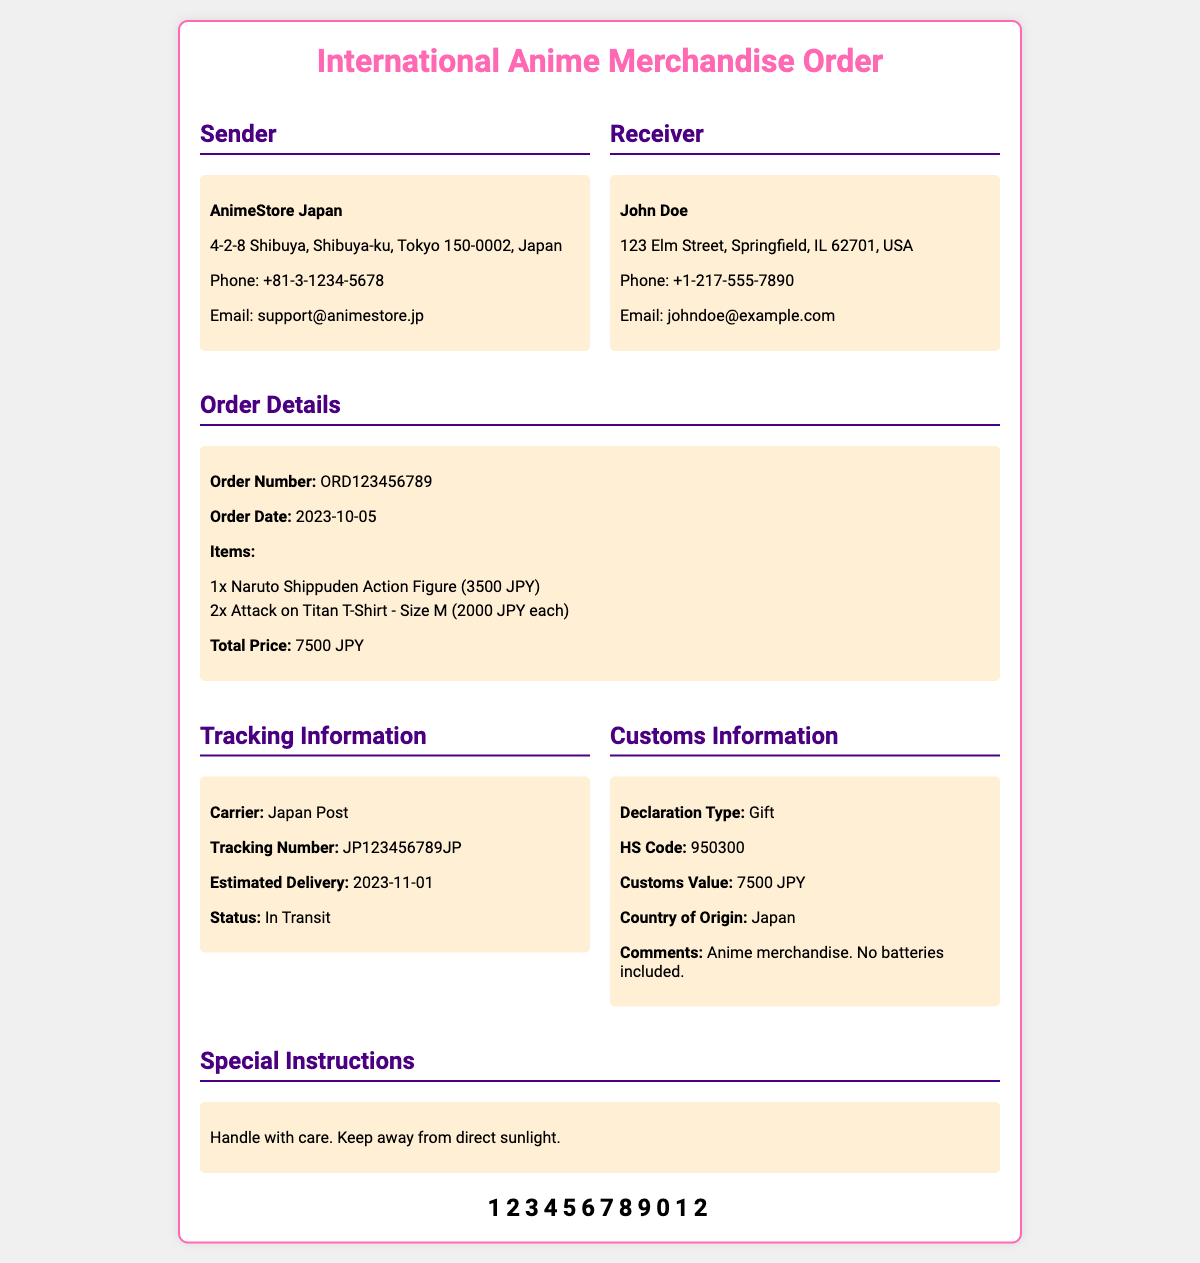What is the sender's name? The sender's name is AnimeStore Japan as listed in the document.
Answer: AnimeStore Japan What is the tracking number? The tracking number provided in the document for this order is JP123456789JP.
Answer: JP123456789JP What is the estimated delivery date? The estimated delivery date mentioned in the document is 2023-11-01.
Answer: 2023-11-01 What is the total price of the order? The total price of the order is calculated as the sum of individual item prices, which is 7500 JPY according to the document.
Answer: 7500 JPY How many Attack on Titan T-Shirts were ordered? The document specifies that 2 Attack on Titan T-Shirts were ordered.
Answer: 2 What is the customs value? The customs value stated in the document for this order is 7500 JPY.
Answer: 7500 JPY What is the declaration type for customs? The document indicates that the declaration type for customs is a Gift.
Answer: Gift What are the special instructions for handling? The special instructions noted in the document are to handle with care and keep away from direct sunlight.
Answer: Handle with care. Keep away from direct sunlight What is the country of origin for the items? According to the document, the country of origin for the items is Japan.
Answer: Japan 